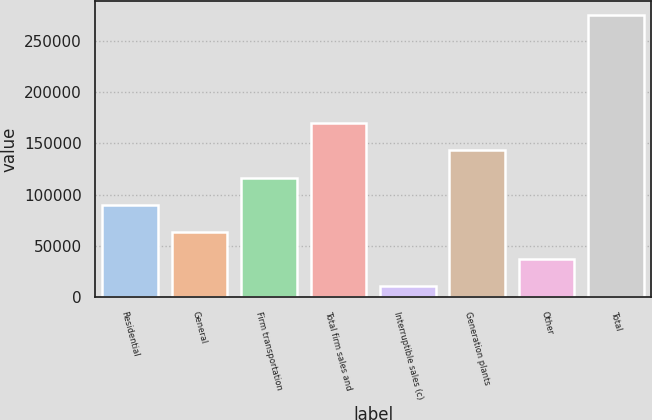Convert chart to OTSL. <chart><loc_0><loc_0><loc_500><loc_500><bar_chart><fcel>Residential<fcel>General<fcel>Firm transportation<fcel>Total firm sales and<fcel>Interruptible sales (c)<fcel>Generation plants<fcel>Other<fcel>Total<nl><fcel>90162.1<fcel>63741.4<fcel>116583<fcel>169424<fcel>10900<fcel>143004<fcel>37320.7<fcel>275107<nl></chart> 